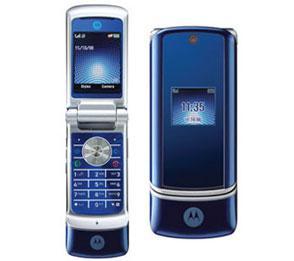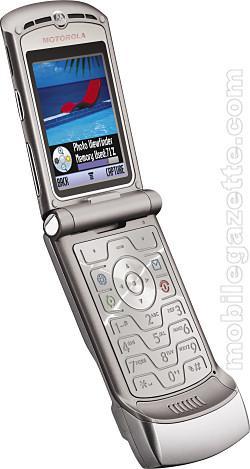The first image is the image on the left, the second image is the image on the right. Examine the images to the left and right. Is the description "The left image contains one diagonally-displayed black phone with a picture on its screen and its front slid partly up to reveal its keypad." accurate? Answer yes or no. No. The first image is the image on the left, the second image is the image on the right. Given the left and right images, does the statement "There are at least three phones side by side in one of the pictures." hold true? Answer yes or no. No. 